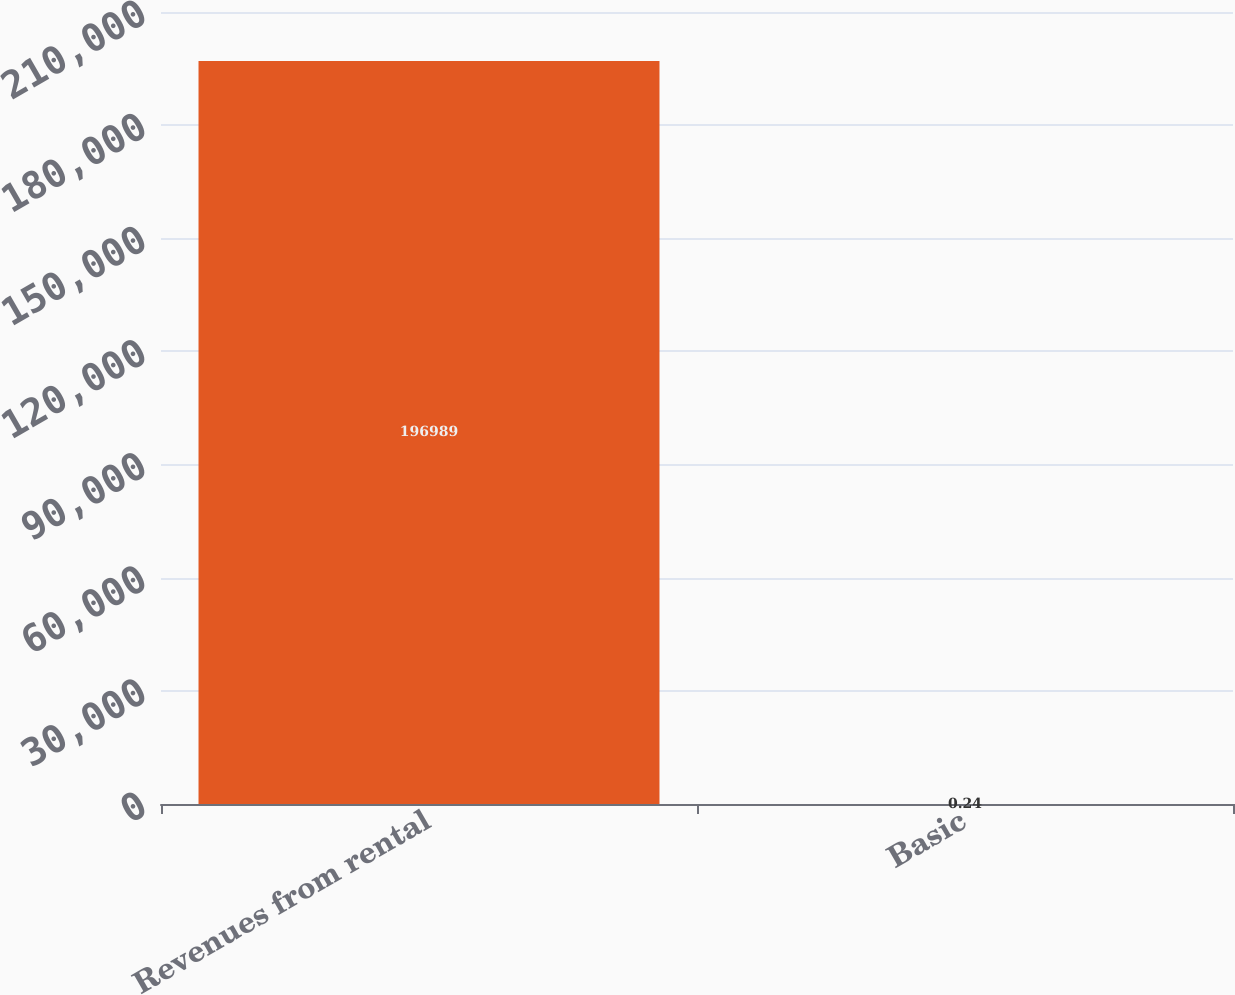Convert chart. <chart><loc_0><loc_0><loc_500><loc_500><bar_chart><fcel>Revenues from rental<fcel>Basic<nl><fcel>196989<fcel>0.24<nl></chart> 